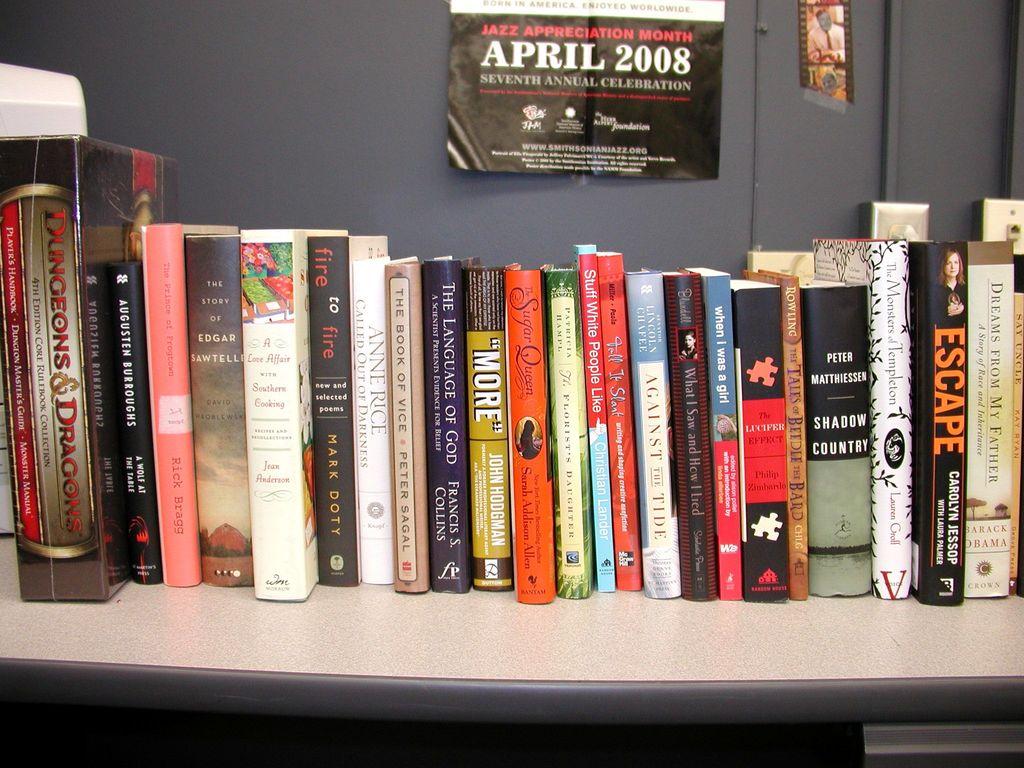When is special about april 2008?
Provide a succinct answer. Jazz appreciation month. 